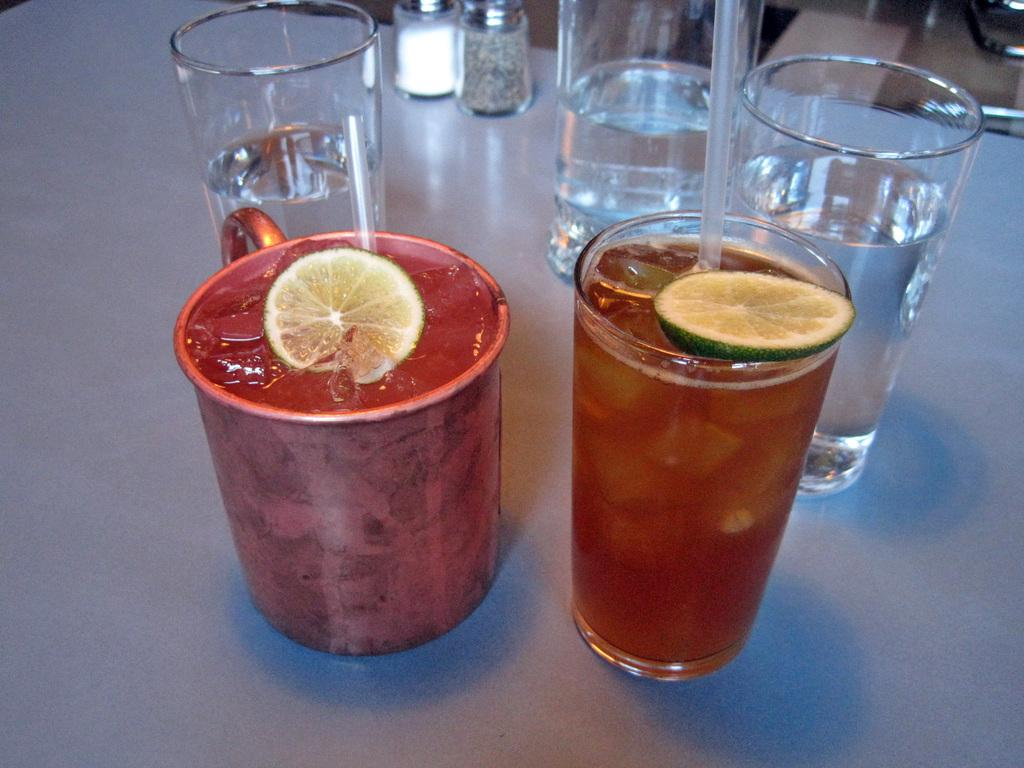What objects are present in the image? There are glasses in the image. What is the color of the surface on which the glasses are placed? The glasses are on a white surface. What is contained within the glasses? There is liquid in the glasses. What type of oatmeal is being served in the glasses? There is no oatmeal present in the image; the glasses contain liquid. Is the sister wearing a scarf in the image? There is no person, let alone a sister, present in the image. 